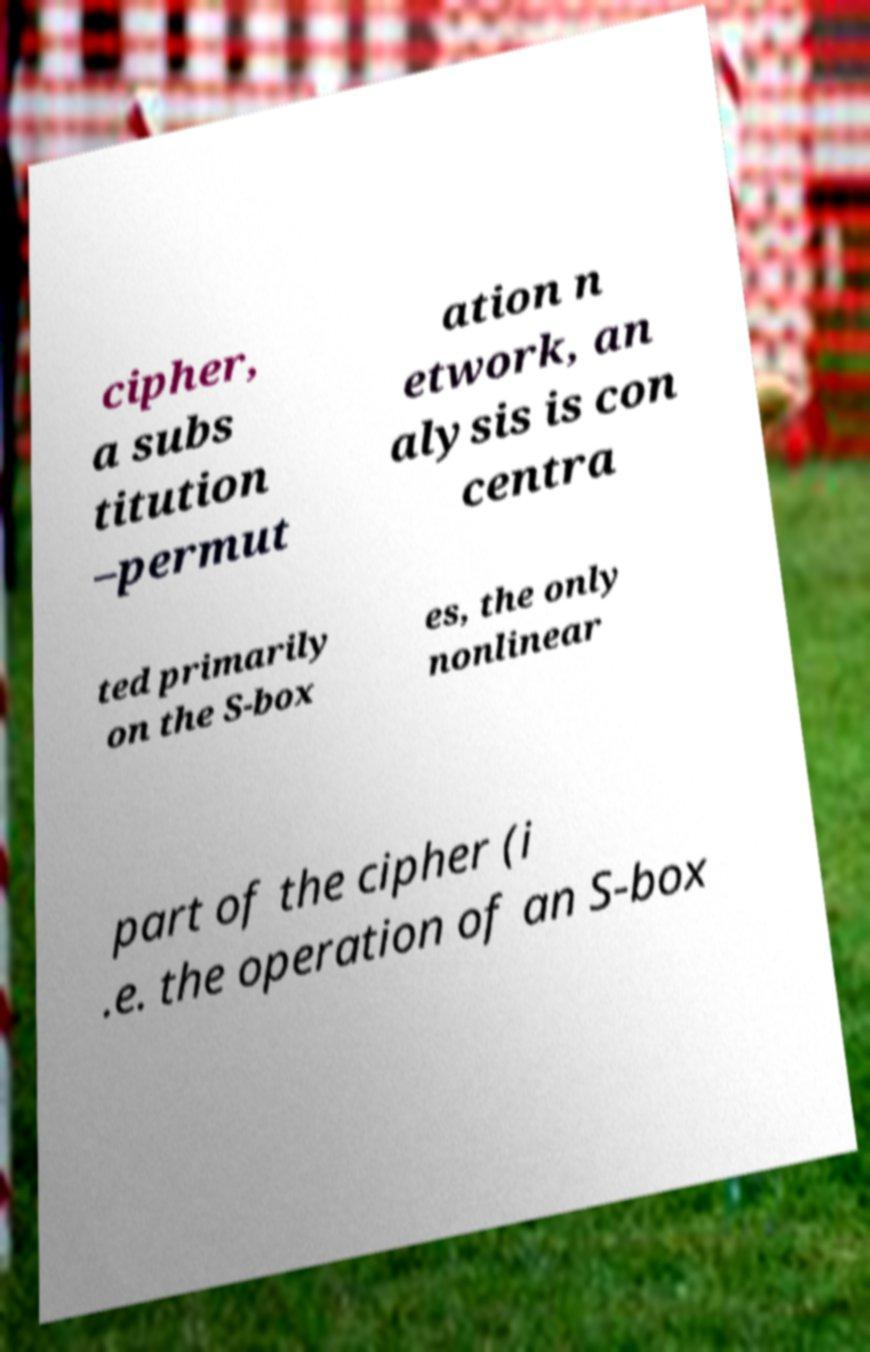Could you assist in decoding the text presented in this image and type it out clearly? cipher, a subs titution –permut ation n etwork, an alysis is con centra ted primarily on the S-box es, the only nonlinear part of the cipher (i .e. the operation of an S-box 